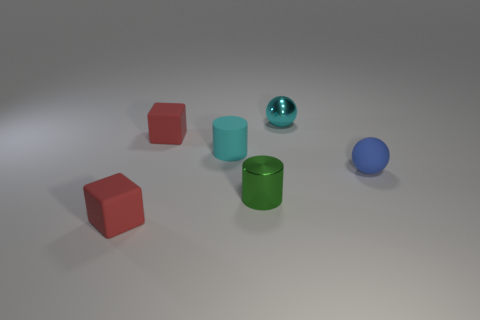Add 1 tiny balls. How many objects exist? 7 Subtract all blocks. How many objects are left? 4 Add 6 small cyan cylinders. How many small cyan cylinders exist? 7 Subtract 0 red spheres. How many objects are left? 6 Subtract all red blocks. Subtract all metal cylinders. How many objects are left? 3 Add 3 red rubber cubes. How many red rubber cubes are left? 5 